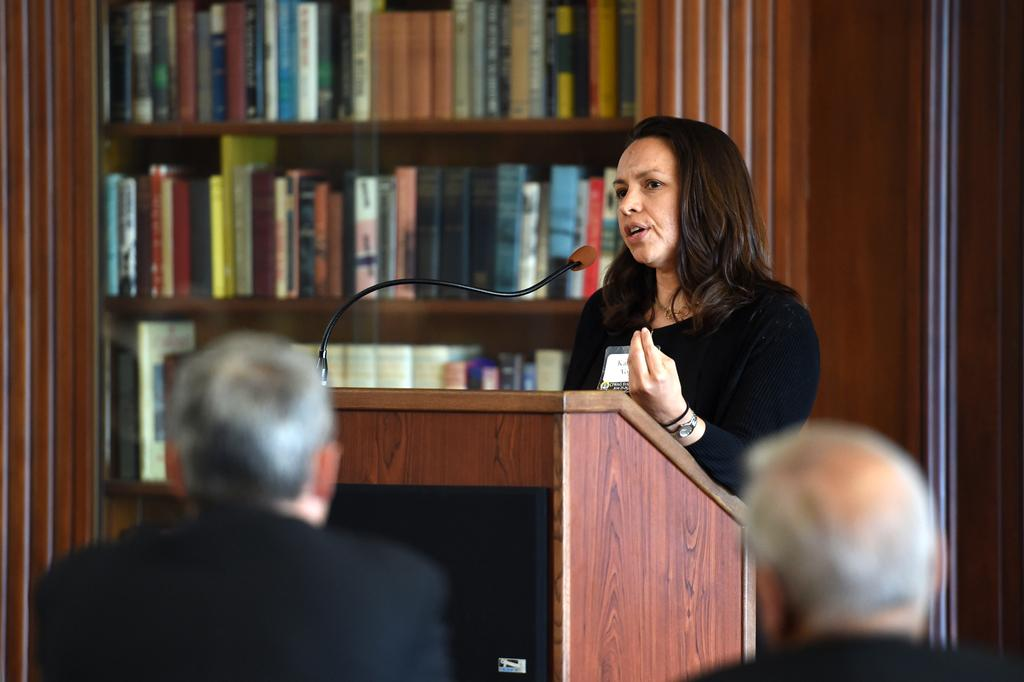How many people are in the image? There are people in the image, but the exact number is not specified. What is the woman in the image doing? The woman is standing in front of a speaker stand and holding a microphone. What can be seen in the background of the image? There are shelves with books in the background of the image. What type of yarn is the woman using to hold the microphone in the image? There is no yarn present in the image; the woman is holding the microphone with her hand. Can you see any fangs on the people in the image? There is no mention of fangs or any other unusual features on the people in the image. 